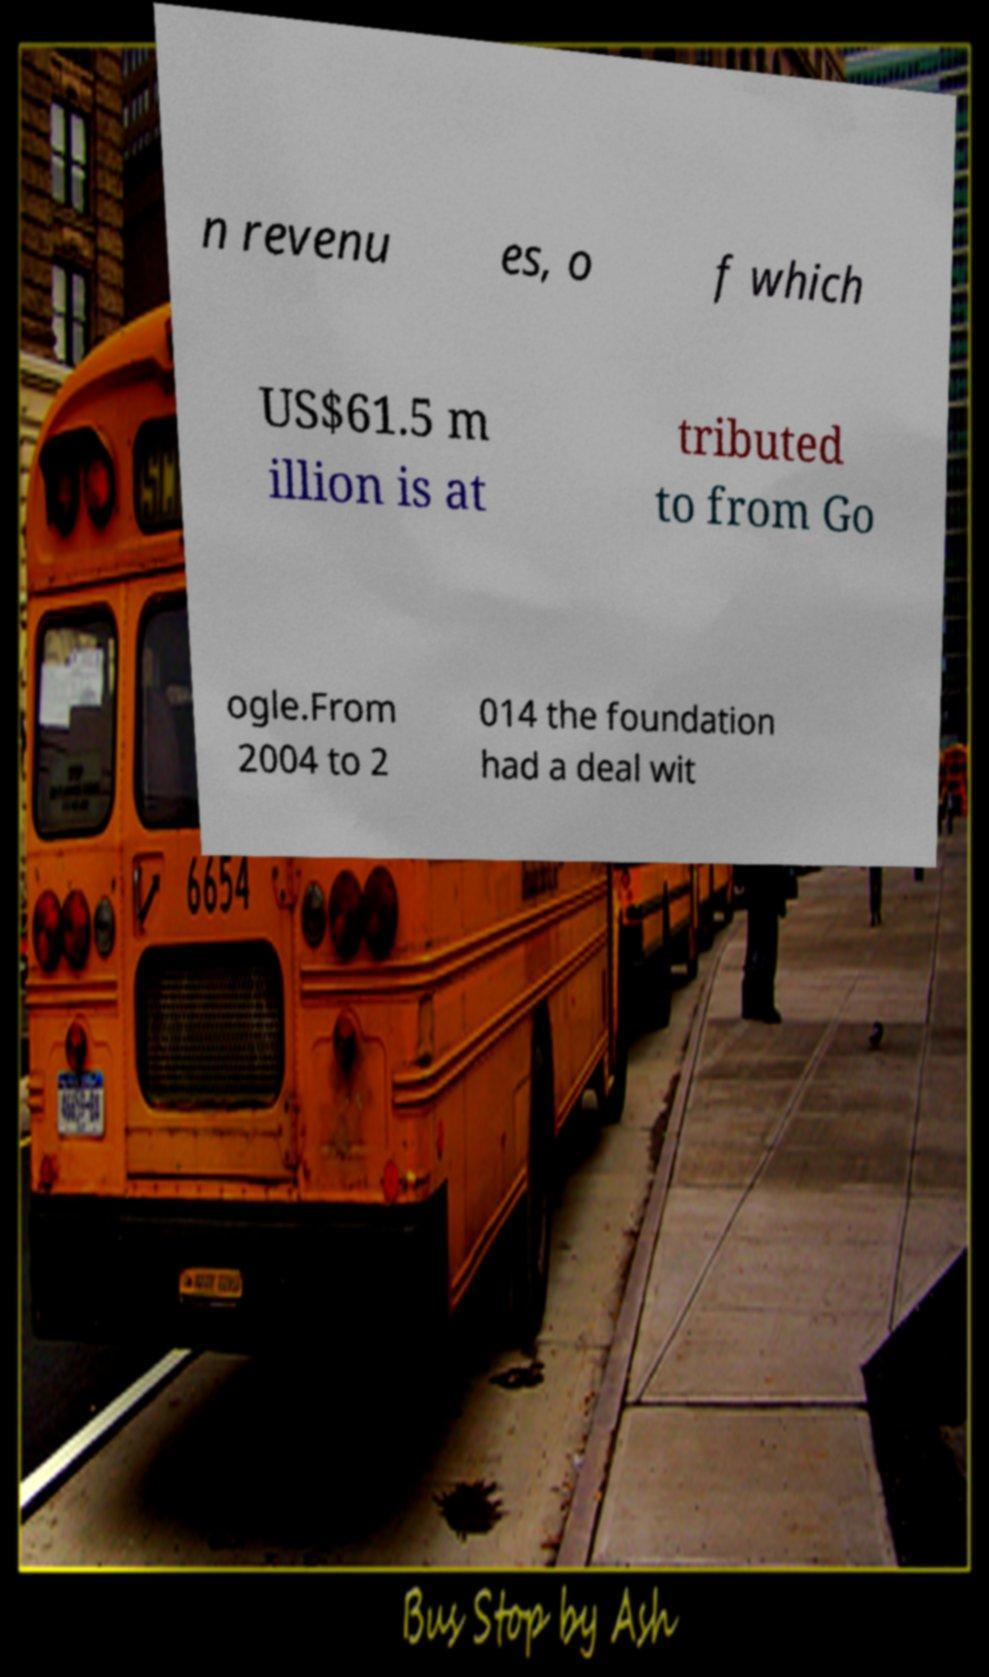Could you extract and type out the text from this image? n revenu es, o f which US$61.5 m illion is at tributed to from Go ogle.From 2004 to 2 014 the foundation had a deal wit 